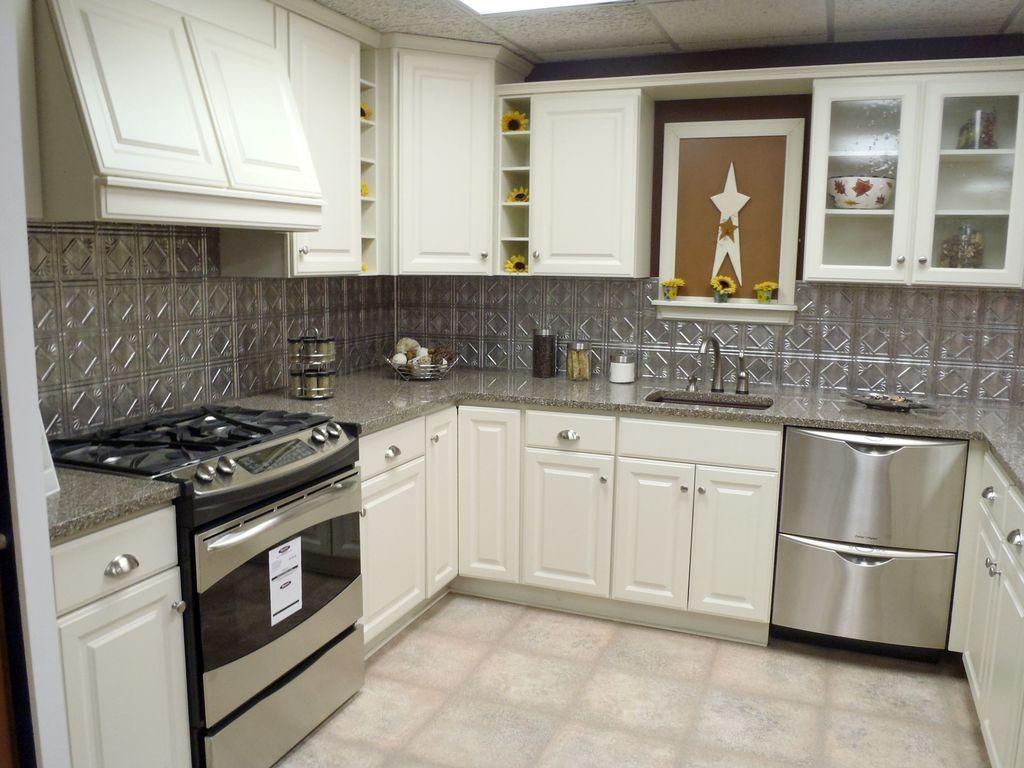How would you summarize this image in a sentence or two? In the foreground of this image, on the bottom, there is the floor and this image is taken in a kitchen, where we can see stove, slab, few objects in the baskets, few containers, sink and cupboards. On the top, there are few cupboards and a light to the ceiling. 